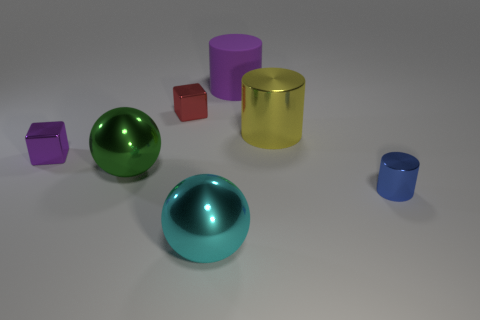Is there a small shiny block of the same color as the rubber object?
Provide a short and direct response. Yes. There is a metal cylinder in front of the green metal thing; is it the same size as the sphere that is in front of the tiny blue metallic object?
Give a very brief answer. No. How big is the shiny object that is behind the green thing and on the right side of the red object?
Offer a very short reply. Large. There is a big rubber cylinder; is its color the same as the small shiny object left of the green metallic object?
Give a very brief answer. Yes. Are there more green spheres than large blue metal balls?
Your response must be concise. Yes. Is there any other thing that is the same color as the large shiny cylinder?
Offer a terse response. No. What number of other objects are the same size as the purple shiny cube?
Your response must be concise. 2. What material is the large purple object that is behind the large sphere that is in front of the large metallic ball that is behind the large cyan metal object made of?
Your answer should be compact. Rubber. Is the tiny blue cylinder made of the same material as the small block behind the big yellow metallic thing?
Offer a terse response. Yes. Are there fewer large yellow objects that are to the left of the big green metallic sphere than purple shiny cubes that are to the right of the big cyan thing?
Your answer should be compact. No. 